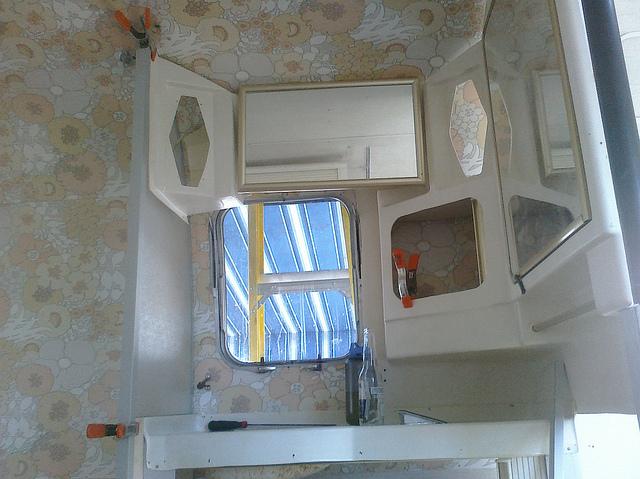Are there two mirrors?
Short answer required. Yes. What is on the wall?
Quick response, please. Window. What is outside the window?
Give a very brief answer. Ladder. 